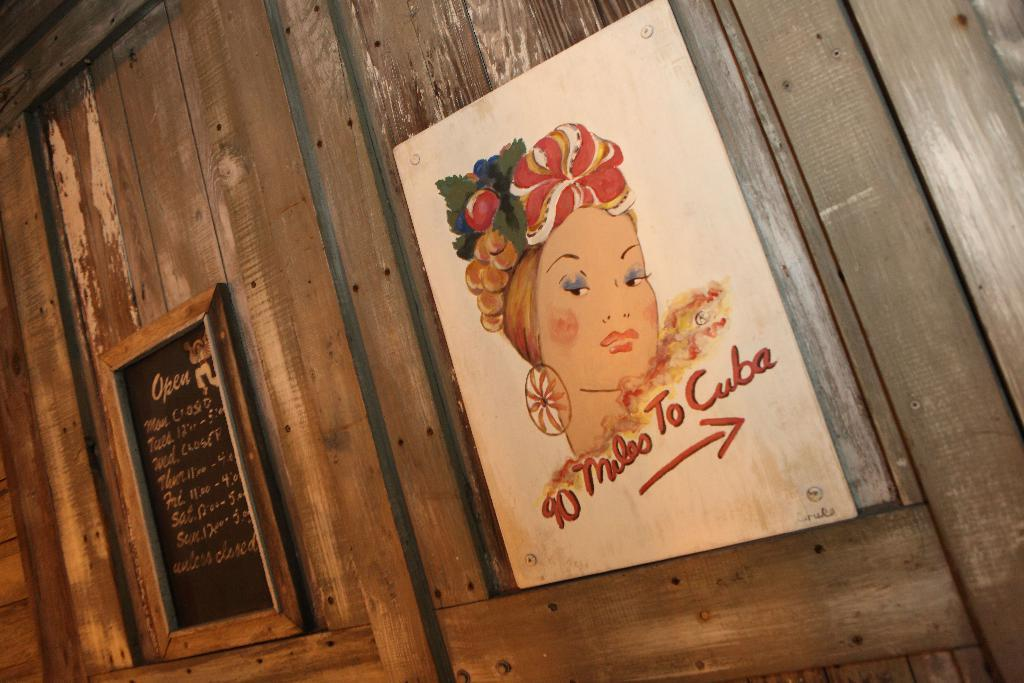Provide a one-sentence caption for the provided image. picture of womans head on wall that states 10 miles to Cuba. 